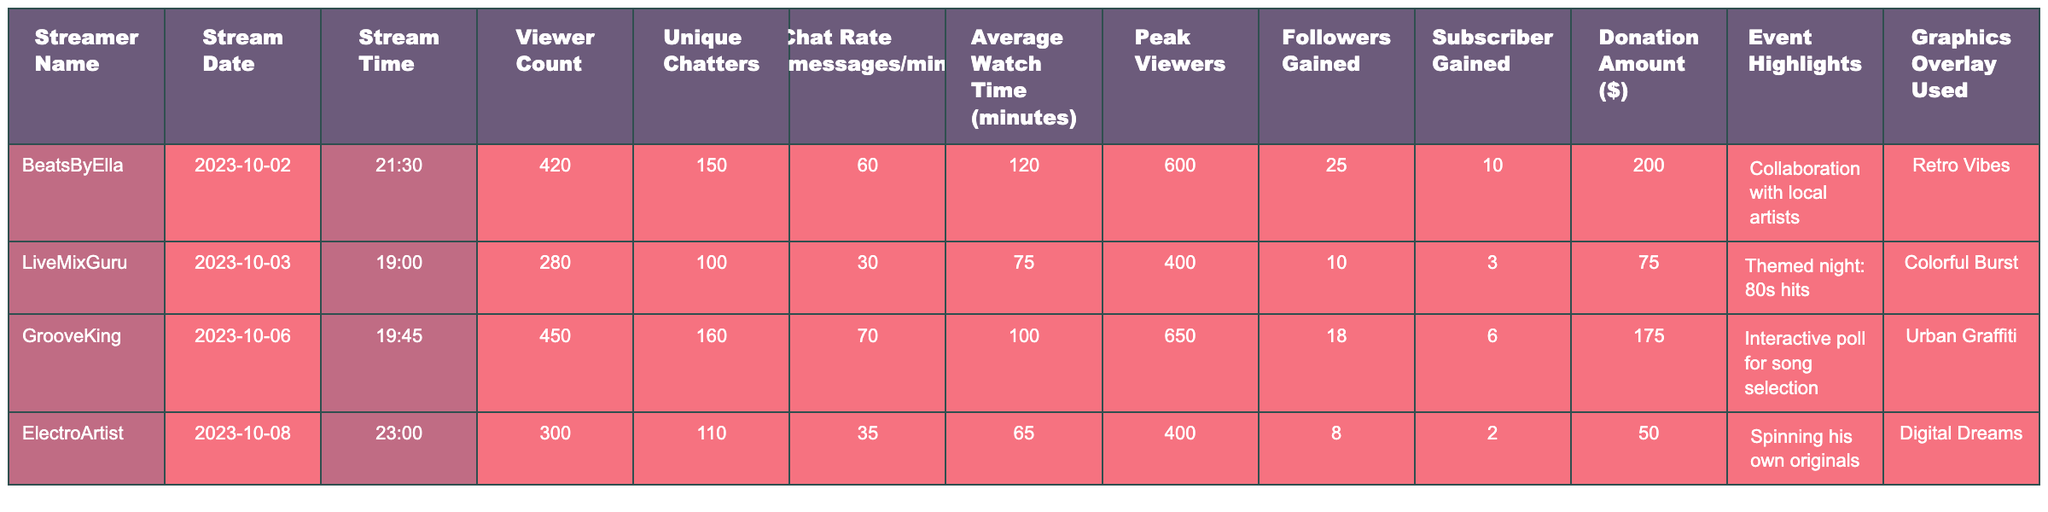What was the highest viewer count during the live DJ sets? The highest viewer count in the table is 450, which corresponds to the stream by GrooveKing on October 6, 2023.
Answer: 450 Which stream had the most unique chatters? The stream with the most unique chatters is by BeatsByElla, with a total of 150 unique chatters on October 2, 2023.
Answer: 150 What is the average watch time across all streams? The average watch time is calculated by summing the average watch times of all streams (120 + 75 + 100 + 65) = 360, then dividing by the number of streams (4), resulting in an average watch time of 90 minutes.
Answer: 90 Did any stream gain more than 20 followers? Yes, the stream by BeatsByElla gained 25 followers, which is more than 20.
Answer: Yes Which graphics overlay was used in the most streams? There are two unique graphics overlays: "Retro Vibes" for BeatsByElla and "Urban Graffiti" for GrooveKing, used once each, while the others were used only once. Thus, there is no single most used overlay.
Answer: None What is the total donation amount from all streams? The total donation amount is calculated by adding the donation amounts of all streams: (200 + 75 + 175 + 50) = 500.
Answer: 500 Was the peak viewer count higher for LiveMixGuru than ElectroArtist? Yes, LiveMixGuru had a peak viewer count of 400, which is higher than ElectroArtist's peak of 400. Since they are equal, the answer is no.
Answer: No What was the chat rate for GrooveKing? The chat rate for GrooveKing is 70 messages per minute, as indicated in his row of the table.
Answer: 70 Which streamer had the least average watch time? The streamer with the least average watch time is ElectroArtist, with an average watch time of 65 minutes.
Answer: 65 How many total subscribers were gained across all streams? The total subscribers gained is computed by summing the subscribers gained from each stream: (10 + 3 + 6 + 2) = 21 subscribers.
Answer: 21 